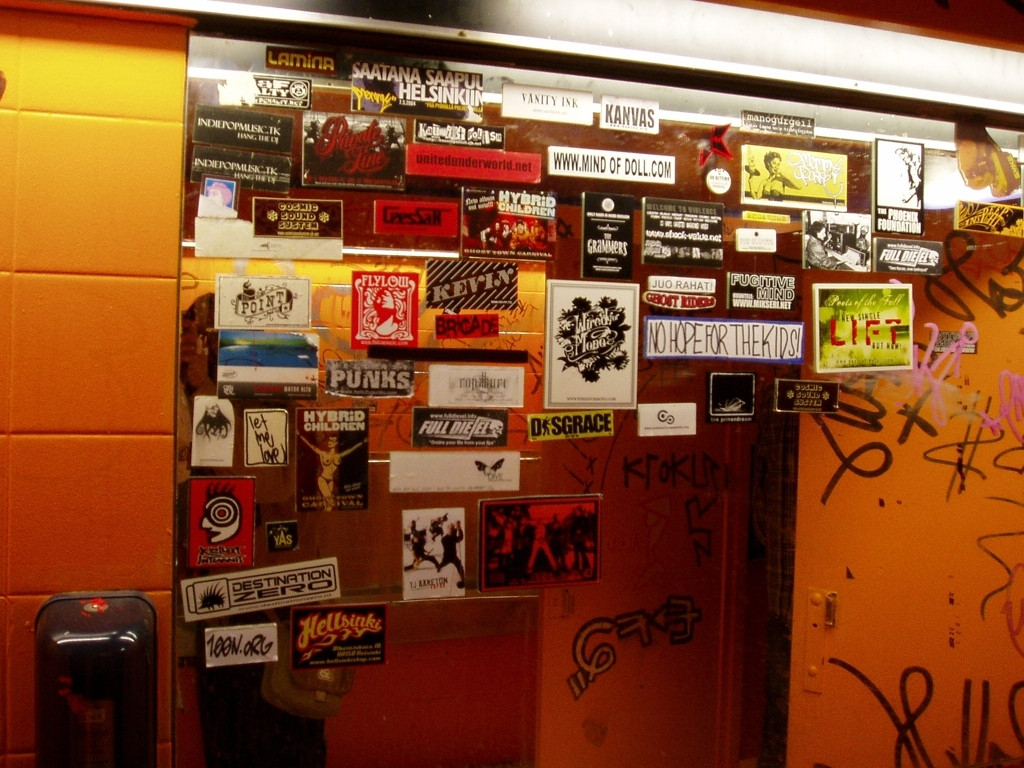What can we infer about the location where this photo was taken? Based on the variety of stickers largely promoting music and cultural events, we can infer that this location is likely an urban area with a thriving alternative or underground scene. It could be the exterior of a venue, a cultural hotspot, or a communal area popular among youths and artists. The graffiti adds to the urban feel, indicating that this might be a place where street art is tolerated or even encouraged, resonating with a city's dynamic and rebellious spirit. 